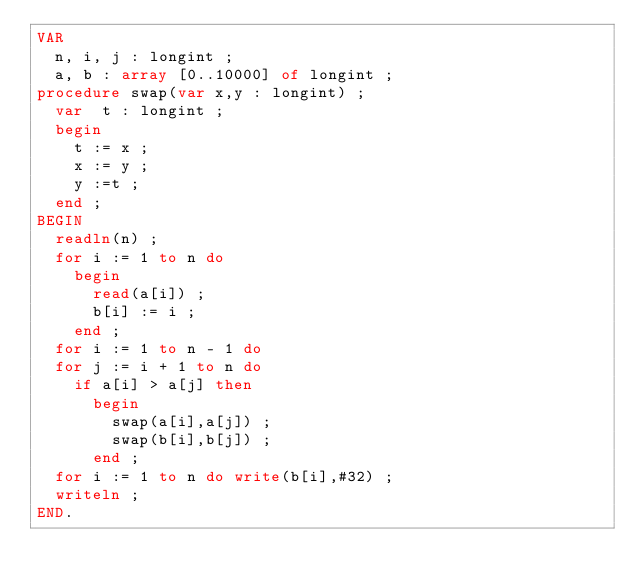Convert code to text. <code><loc_0><loc_0><loc_500><loc_500><_Pascal_>VAR
  n, i, j : longint ;
  a, b : array [0..10000] of longint ;
procedure swap(var x,y : longint) ;
  var  t : longint ;
  begin
    t := x ;
    x := y ;
    y :=t ;
  end ;
BEGIN
  readln(n) ;
  for i := 1 to n do
    begin
      read(a[i]) ;
      b[i] := i ;
    end ;
  for i := 1 to n - 1 do
  for j := i + 1 to n do
    if a[i] > a[j] then
      begin
        swap(a[i],a[j]) ;
        swap(b[i],b[j]) ;
      end ;
  for i := 1 to n do write(b[i],#32) ;
  writeln ;
END.</code> 